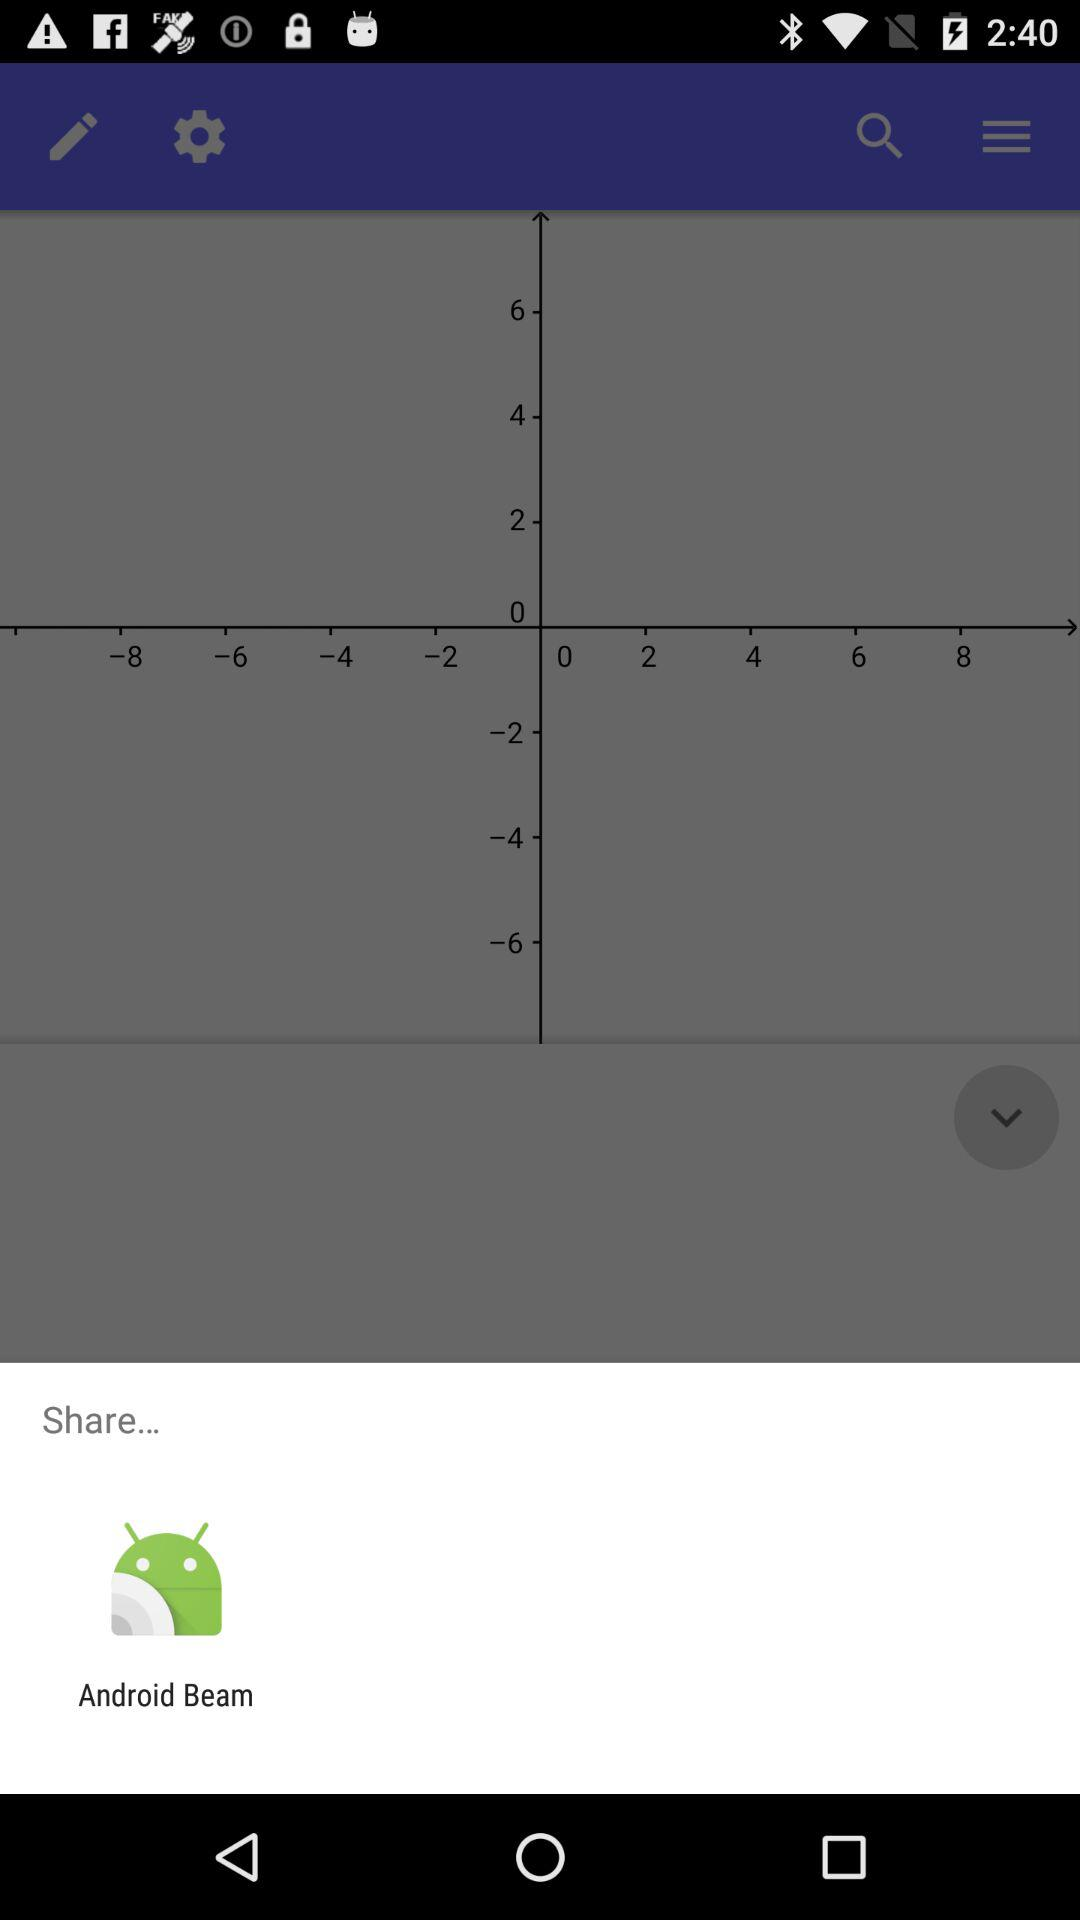What is the share option? The option is "Android Beam". 